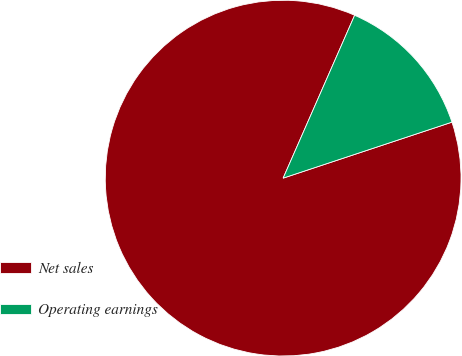Convert chart. <chart><loc_0><loc_0><loc_500><loc_500><pie_chart><fcel>Net sales<fcel>Operating earnings<nl><fcel>86.68%<fcel>13.32%<nl></chart> 